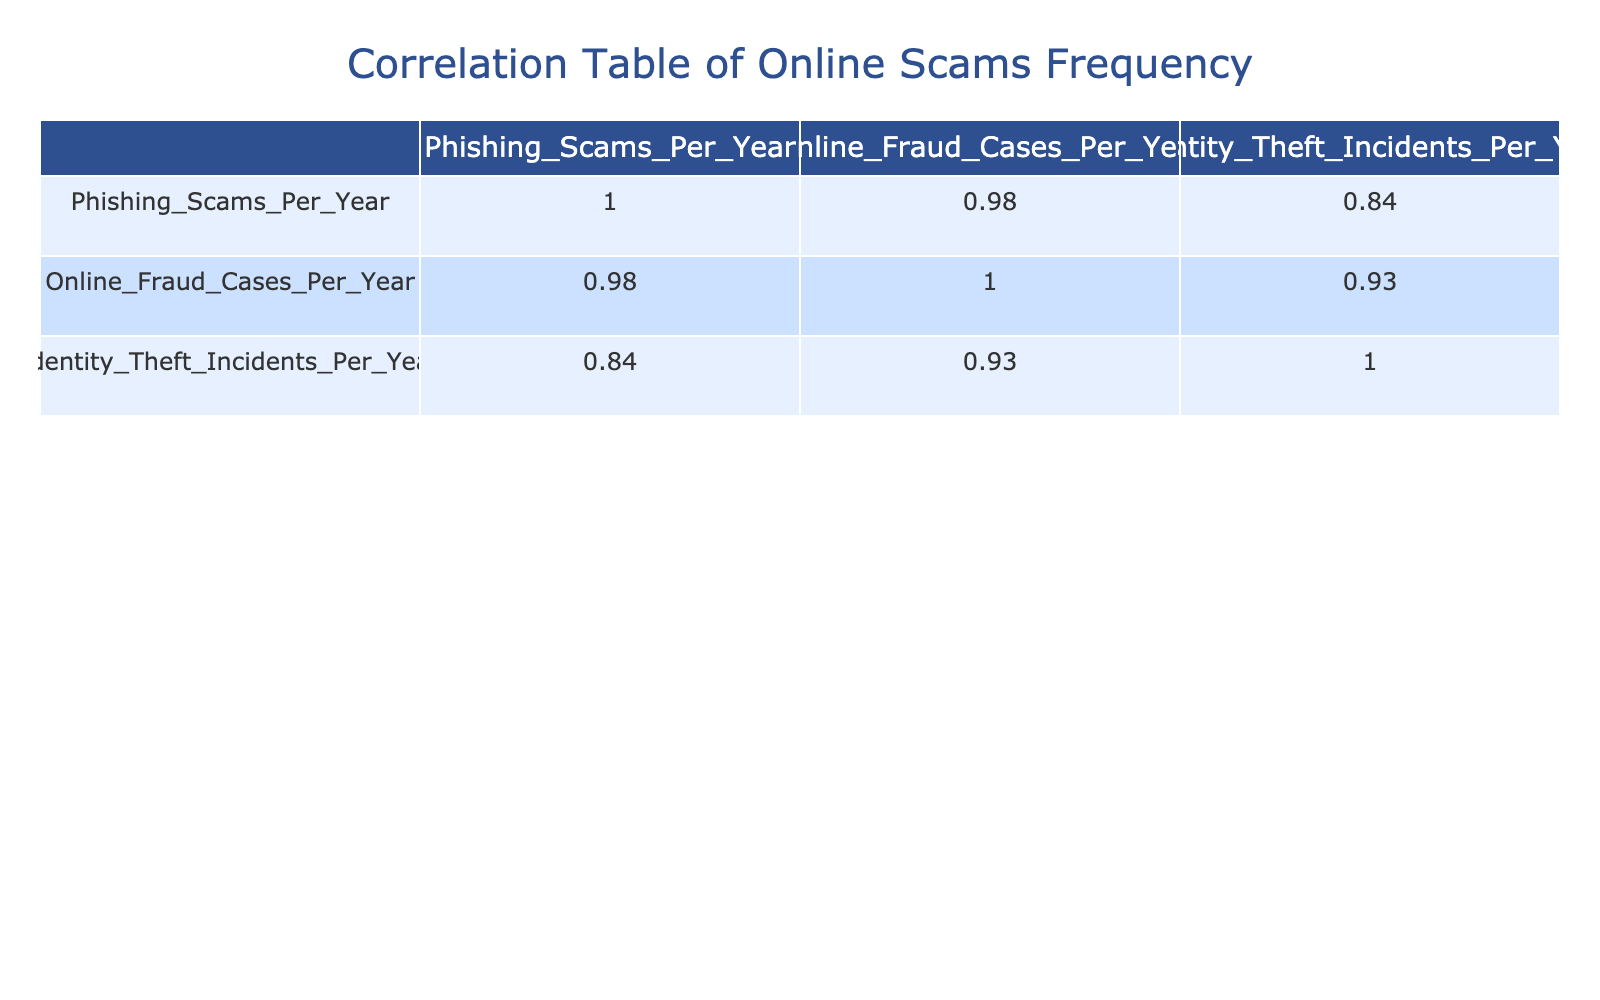What is the correlation between phishing scams and identity theft incidents? The correlation value can be found by looking at the intersection of the 'Phishing_Scams_Per_Year' row and 'Identity_Theft_Incidents_Per_Year' column in the correlation table. Upon checking the table, the correlation value is approximately 0.90, indicating a strong positive relationship between these two variables.
Answer: 0.90 Which age group has the highest number of online fraud cases per year? To find the highest number, we can look at the 'Online_Fraud_Cases_Per_Year' column and identify the largest value. From the table, the age group 25-34 has the highest with 25 cases.
Answer: 25-34 Is it true that individuals aged 65 and above experience more phishing scams than those aged 55-64? We compare the phishing scams for both age groups by looking at the 'Phishing_Scams_Per_Year' values. The 65 and above age group has 10, while the 55-64 age group has 15. Since 10 is less than 15, the statement is false.
Answer: No What is the total number of phishing scams across all age groups? To find the total, we add up all the values in the 'Phishing_Scams_Per_Year' column: 30 + 40 + 35 + 25 + 15 + 10 = 155. Thus, the total number of phishing scams is 155.
Answer: 155 If the average number of identity theft incidents across all age groups is calculated, what is the result? We sum the 'Identity_Theft_Incidents_Per_Year' values: 5 + 10 + 8 + 7 + 6 + 3 = 39. There are 6 age groups, so the average is 39/6 = 6.5.
Answer: 6.5 Which age group has the least number of identity theft incidents, and how many incidents do they experience? By looking at the 'Identity_Theft_Incidents_Per_Year' column, we can identify the least value. The age group 65 and above has the fewest incidents at 3.
Answer: 65 and above, 3 What is the correlation between online fraud cases and age groups? The correlation would require examining the specific data relating online fraud cases to the age groups. The correlation value is approximately -0.88, indicating a strong negative correlation; as age increases, online fraud cases decrease.
Answer: -0.88 Are phishing scams more frequent in the age group 25-34 compared to the 45-54 group? We will compare the phishing scams for both groups: 25-34 has 40 while 45-54 has 25. Since 40 is greater than 25, the statement is true.
Answer: Yes 